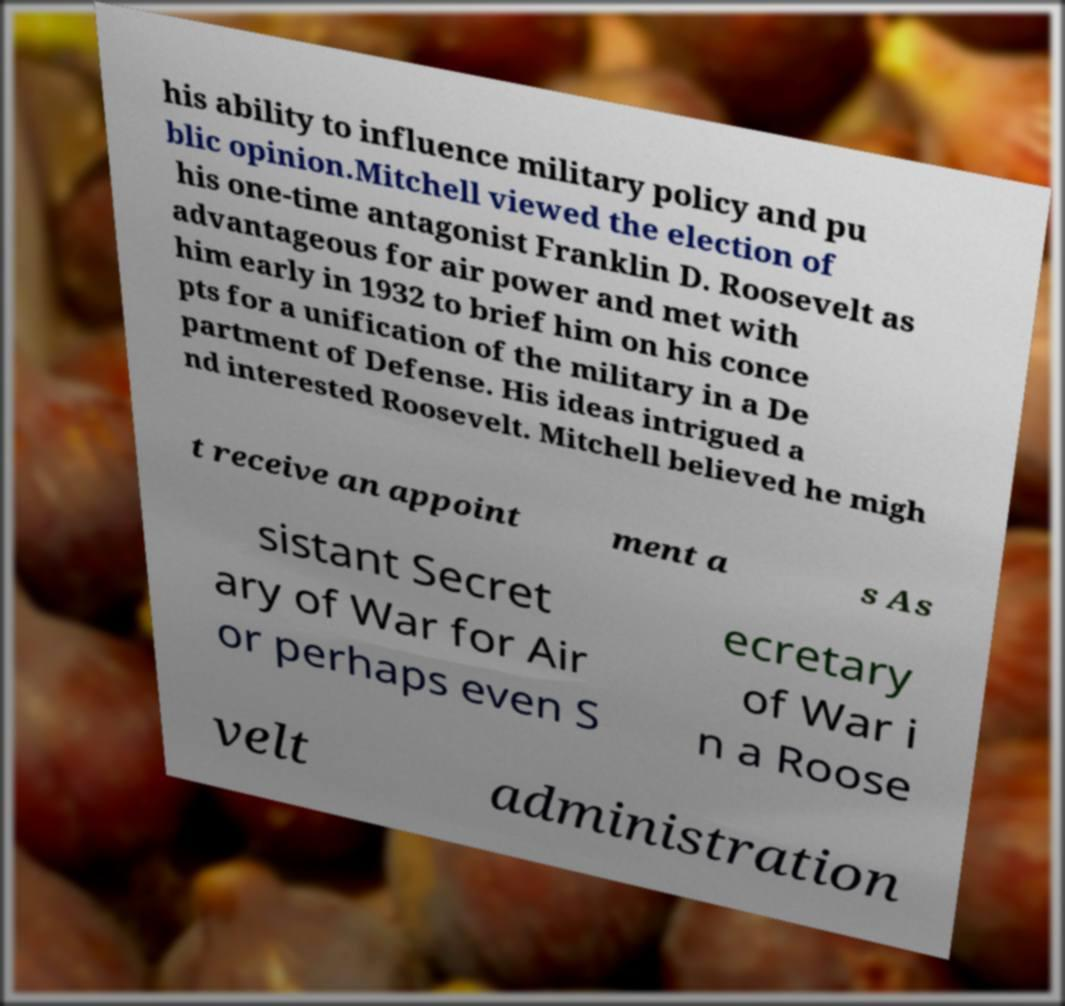Could you assist in decoding the text presented in this image and type it out clearly? his ability to influence military policy and pu blic opinion.Mitchell viewed the election of his one-time antagonist Franklin D. Roosevelt as advantageous for air power and met with him early in 1932 to brief him on his conce pts for a unification of the military in a De partment of Defense. His ideas intrigued a nd interested Roosevelt. Mitchell believed he migh t receive an appoint ment a s As sistant Secret ary of War for Air or perhaps even S ecretary of War i n a Roose velt administration 